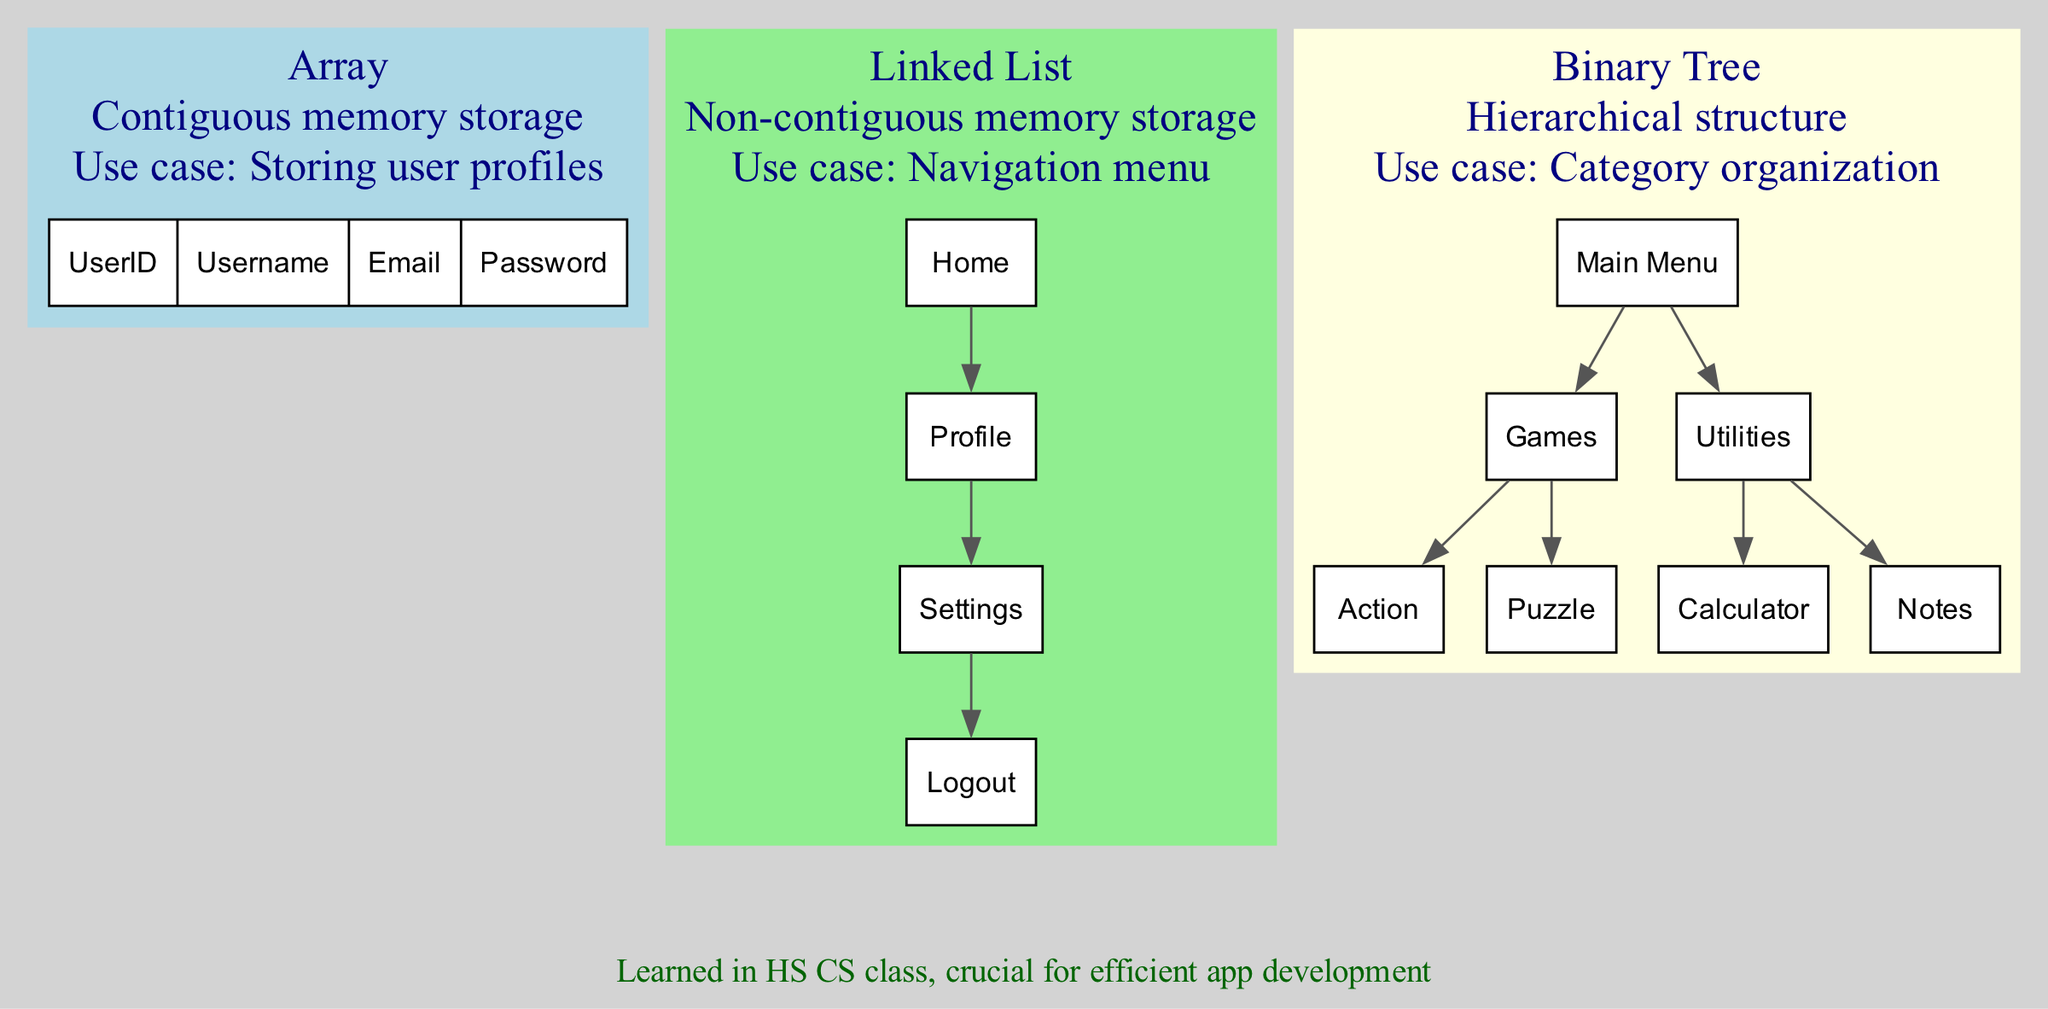What is the root of the binary tree? The binary tree has a hierarchical structure where the topmost node is referred to as the root. According to the diagram, the root node is labeled as "Main Menu."
Answer: Main Menu How many nodes are in the linked list? The linked list consists of multiple nodes which have been labeled in the diagram. There are four nodes labeled as "Home," "Profile," "Settings," and "Logout." Thus, the total number of nodes in the linked list is four.
Answer: 4 What is the use case of the array? Each data structure in the diagram has a specific use case described. The use case for the array is mentioned as "Storing user profiles."
Answer: Storing user profiles What is the first child of the binary tree? In the binary tree structure, the root node has two children according to the diagram. The first child of the binary tree listed under the root node is "Games."
Answer: Games What type of memory storage does a linked list utilize? The linked list section of the diagram describes its characteristics. It specifically mentions that a linked list uses "Non-contiguous memory storage."
Answer: Non-contiguous memory storage How many leaf nodes are in the binary tree? A leaf node in a binary tree is defined as any node that does not have any children. In the diagram's binary tree, "Action" and "Puzzle" are leaf nodes under "Games," while "Calculator" and "Notes" are leaf nodes under "Utilities." Thus, there are four leaf nodes total.
Answer: 4 What is the last node in the linked list? The linked list displays a sequential arrangement of nodes. The last node in this arrangement, as shown in the diagram, is "Logout."
Answer: Logout Which data structure is best for a navigation menu? The diagram outlines various use cases for data structures, and it indicates that the linked list is particularly suited for a navigation menu.
Answer: Linked List What are the categories under "Utilities" in the binary tree? The binary tree structure shows various categories, and under the "Utilities" node, the diagram specifies two child nodes, "Calculator" and "Notes."
Answer: Calculator, Notes 